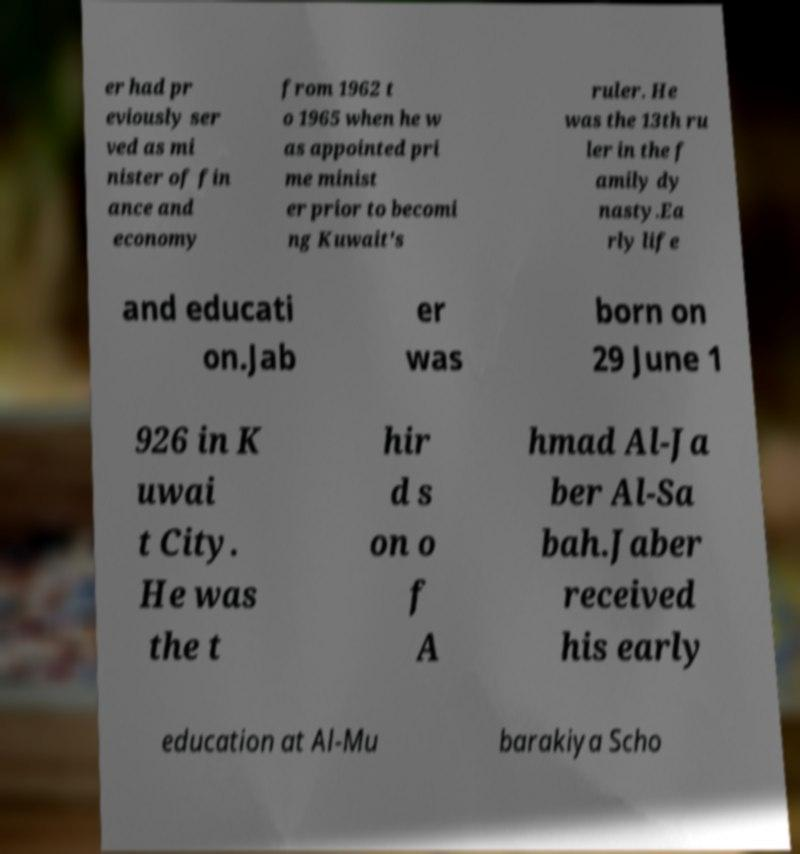Could you assist in decoding the text presented in this image and type it out clearly? er had pr eviously ser ved as mi nister of fin ance and economy from 1962 t o 1965 when he w as appointed pri me minist er prior to becomi ng Kuwait's ruler. He was the 13th ru ler in the f amily dy nasty.Ea rly life and educati on.Jab er was born on 29 June 1 926 in K uwai t City. He was the t hir d s on o f A hmad Al-Ja ber Al-Sa bah.Jaber received his early education at Al-Mu barakiya Scho 